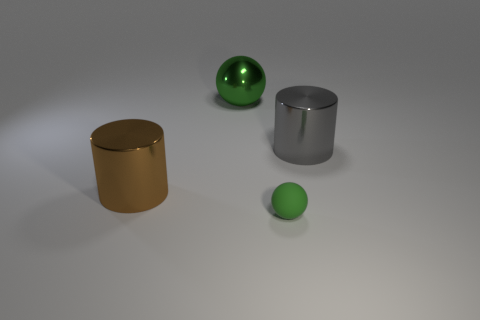Are there any indicators of how these objects might be used? The image alone doesn't provide context for specific use, but based on their shapes and materials, one could imagine the cylinders being parts of furniture or containers, while the balls could be decorative elements or part of a child's toy set. 